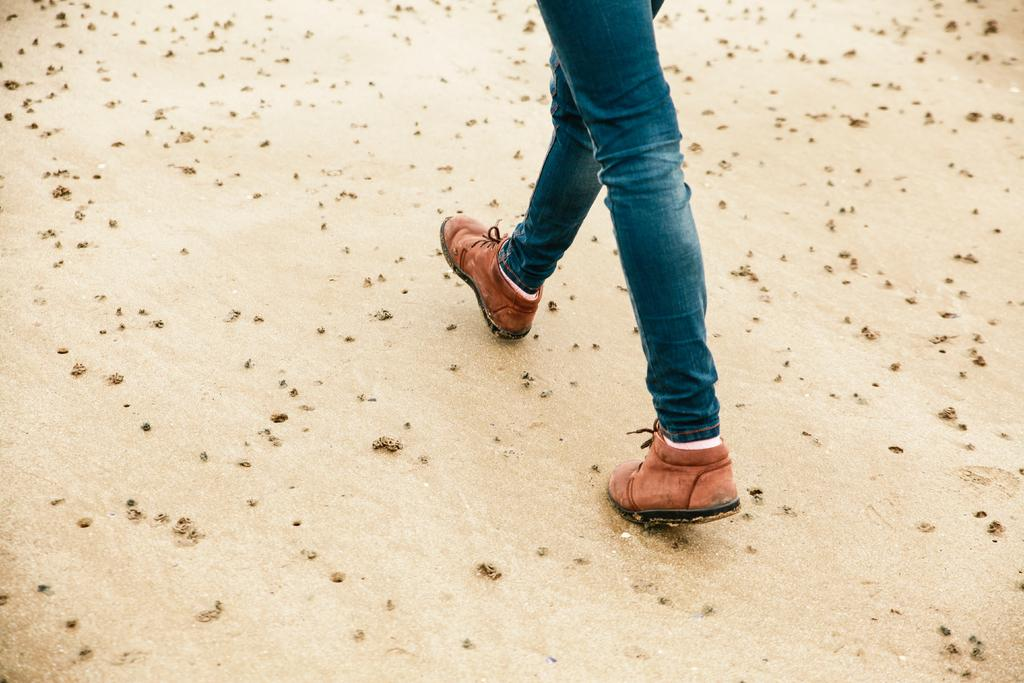What is present in the image? There is a person in the image. What type of clothing is the person wearing? The person is wearing jeans. What color are the shoes the person is wearing? The person is wearing brown color shoes. What type of terrain is visible at the bottom of the image? There is sand visible at the bottom of the image. What type of chicken is the person holding in the image? There is no chicken present in the image. Is the person smiling in the image? The provided facts do not mention the person's facial expression, so we cannot determine if they are smiling or not. What type of work does the person in the image do? The provided facts do not mention the person's occupation, so we cannot determine if they are a farmer or not. 